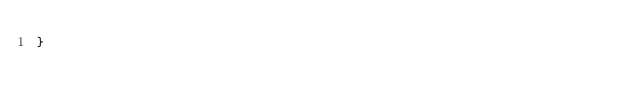<code> <loc_0><loc_0><loc_500><loc_500><_Java_>}
</code> 